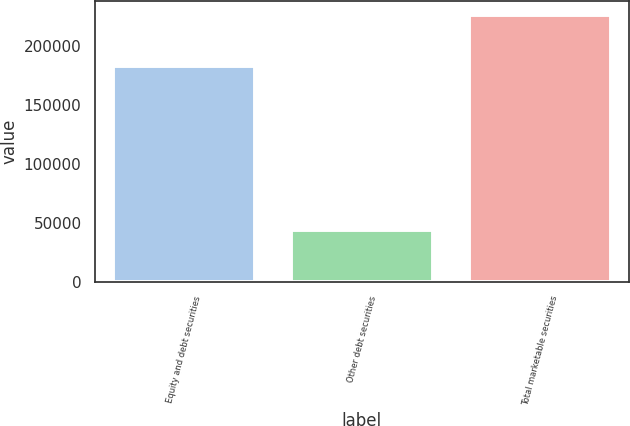Convert chart to OTSL. <chart><loc_0><loc_0><loc_500><loc_500><bar_chart><fcel>Equity and debt securities<fcel>Other debt securities<fcel>Total marketable securities<nl><fcel>182826<fcel>43500<fcel>226326<nl></chart> 